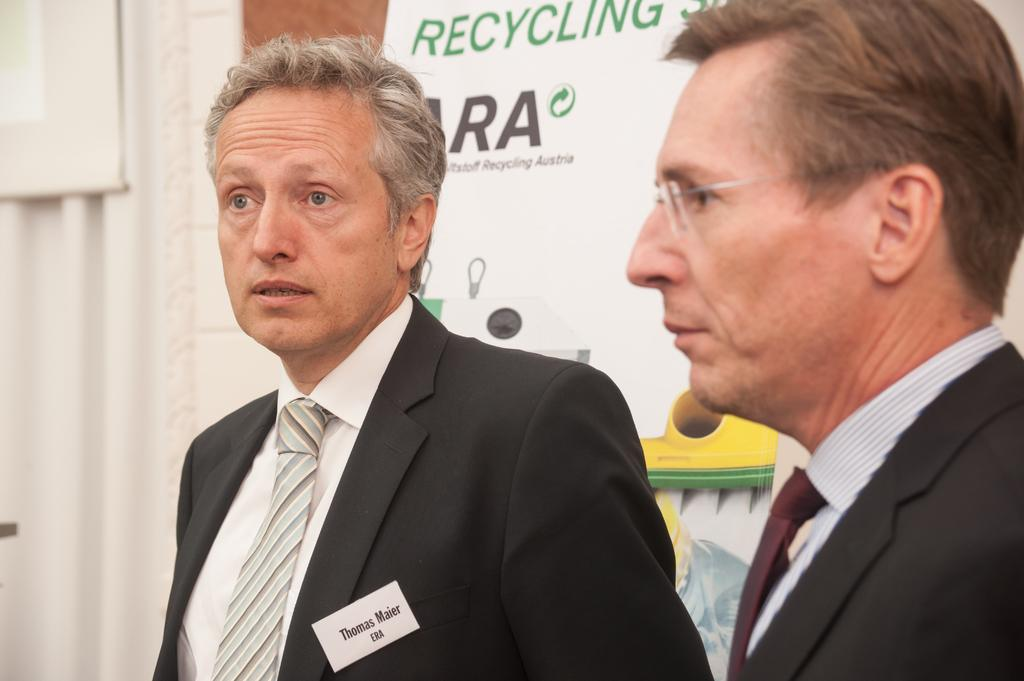How many people are present in the image? There are two persons in the image. What can be seen in the background of the image? There is a board and a wall in the background of the image. What type of doll is sitting on the library shelf in the image? There is no doll or library present in the image. 